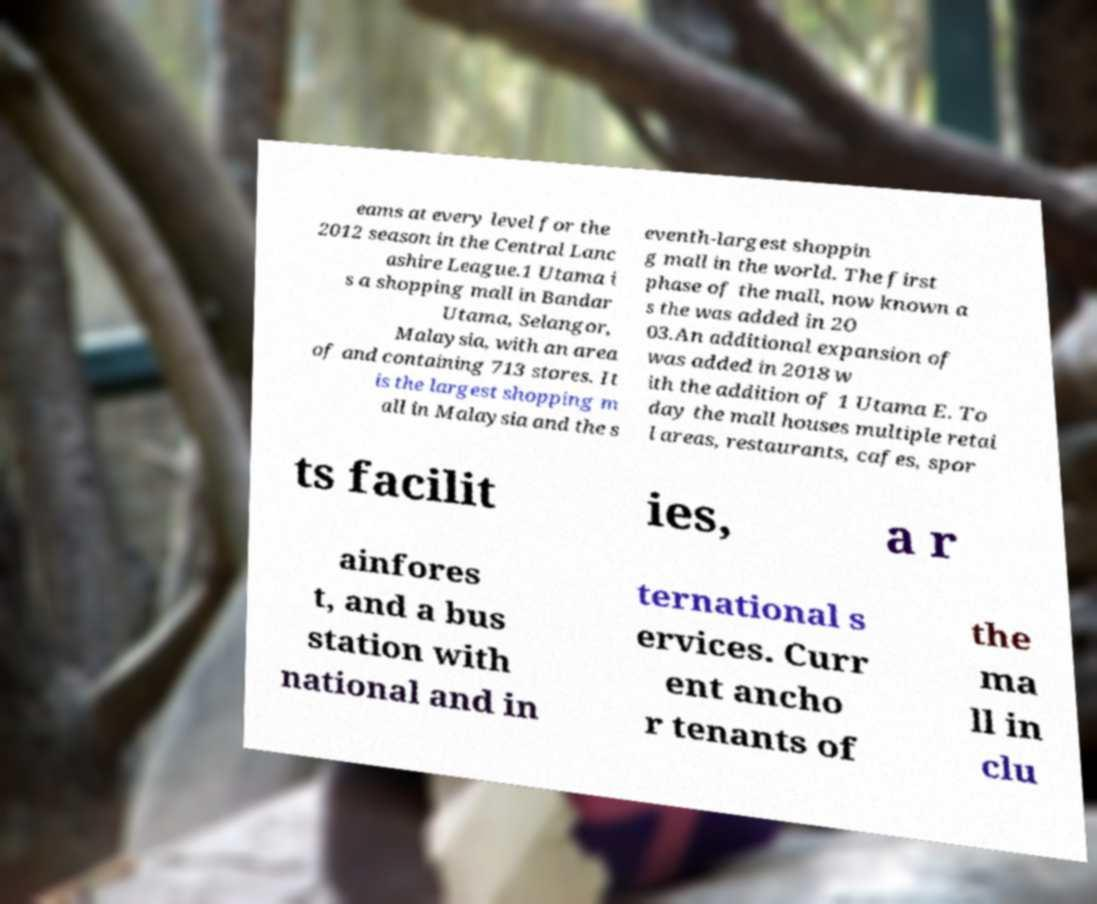Could you extract and type out the text from this image? eams at every level for the 2012 season in the Central Lanc ashire League.1 Utama i s a shopping mall in Bandar Utama, Selangor, Malaysia, with an area of and containing 713 stores. It is the largest shopping m all in Malaysia and the s eventh-largest shoppin g mall in the world. The first phase of the mall, now known a s the was added in 20 03.An additional expansion of was added in 2018 w ith the addition of 1 Utama E. To day the mall houses multiple retai l areas, restaurants, cafes, spor ts facilit ies, a r ainfores t, and a bus station with national and in ternational s ervices. Curr ent ancho r tenants of the ma ll in clu 